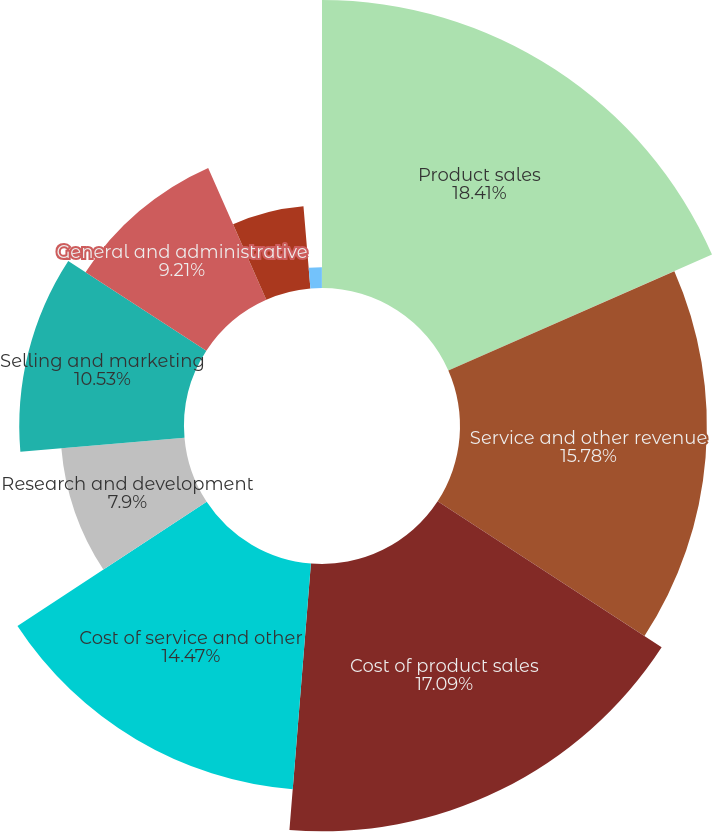Convert chart to OTSL. <chart><loc_0><loc_0><loc_500><loc_500><pie_chart><fcel>Product sales<fcel>Service and other revenue<fcel>Cost of product sales<fcel>Cost of service and other<fcel>Research and development<fcel>Selling and marketing<fcel>General and administrative<fcel>Income from operations<fcel>Interest income<fcel>Interest and other income<nl><fcel>18.41%<fcel>15.78%<fcel>17.09%<fcel>14.47%<fcel>7.9%<fcel>10.53%<fcel>9.21%<fcel>5.27%<fcel>1.33%<fcel>0.01%<nl></chart> 